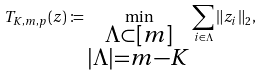<formula> <loc_0><loc_0><loc_500><loc_500>T _ { K , m , p } ( z ) \coloneqq \min _ { \substack { \Lambda \subset [ m ] \\ | \Lambda | = m - K } } \sum _ { i \in \Lambda } \| z _ { i } \| _ { 2 } ,</formula> 